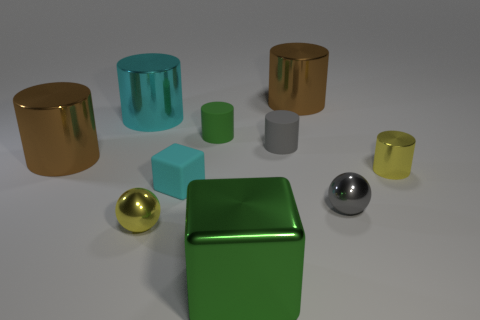What number of small metal things are to the left of the yellow cylinder?
Your answer should be compact. 2. There is a shiny block that is to the right of the small green cylinder; is it the same color as the small rubber cube?
Provide a succinct answer. No. What number of green things are either tiny blocks or tiny objects?
Make the answer very short. 1. The small rubber thing in front of the yellow shiny thing right of the cyan rubber cube is what color?
Give a very brief answer. Cyan. What is the material of the large cylinder that is the same color as the small cube?
Make the answer very short. Metal. The metal sphere that is in front of the gray metal sphere is what color?
Your answer should be compact. Yellow. There is a brown cylinder on the left side of the cyan cylinder; does it have the same size as the small green rubber object?
Make the answer very short. No. There is a thing that is the same color as the large shiny block; what is its size?
Offer a terse response. Small. Are there any green rubber things of the same size as the green rubber cylinder?
Your answer should be very brief. No. Is the color of the large thing that is right of the small gray matte cylinder the same as the large cylinder that is in front of the green rubber thing?
Give a very brief answer. Yes. 